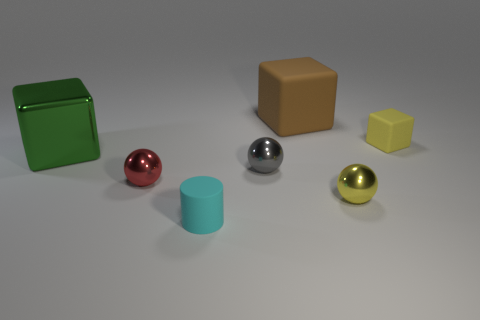What material is the object that is the same color as the small matte block?
Provide a succinct answer. Metal. What color is the shiny object on the left side of the tiny red sphere?
Ensure brevity in your answer.  Green. There is a cyan cylinder to the right of the green block; is it the same size as the large green metallic object?
Ensure brevity in your answer.  No. What size is the metal object that is the same color as the tiny block?
Your response must be concise. Small. Is there another object of the same size as the gray thing?
Your answer should be very brief. Yes. Does the small object that is behind the large green cube have the same color as the rubber thing to the left of the gray thing?
Your answer should be very brief. No. Are there any big metallic cylinders of the same color as the small matte cube?
Your response must be concise. No. What number of other objects are there of the same shape as the brown object?
Your answer should be very brief. 2. What shape is the large thing that is to the right of the small red shiny thing?
Your answer should be very brief. Cube. There is a brown object; is it the same shape as the big object that is on the left side of the small cyan cylinder?
Your answer should be very brief. Yes. 